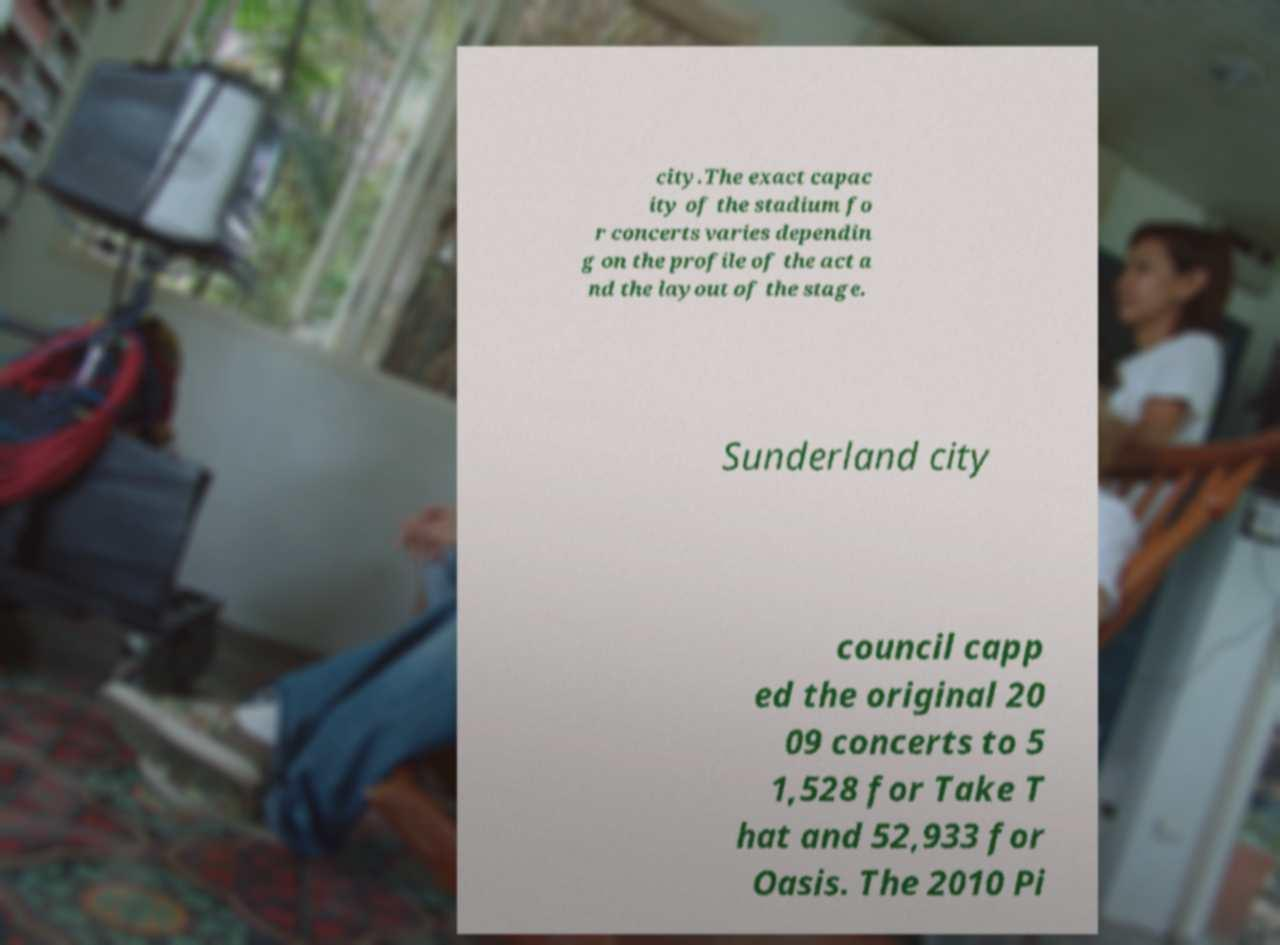Can you accurately transcribe the text from the provided image for me? city.The exact capac ity of the stadium fo r concerts varies dependin g on the profile of the act a nd the layout of the stage. Sunderland city council capp ed the original 20 09 concerts to 5 1,528 for Take T hat and 52,933 for Oasis. The 2010 Pi 